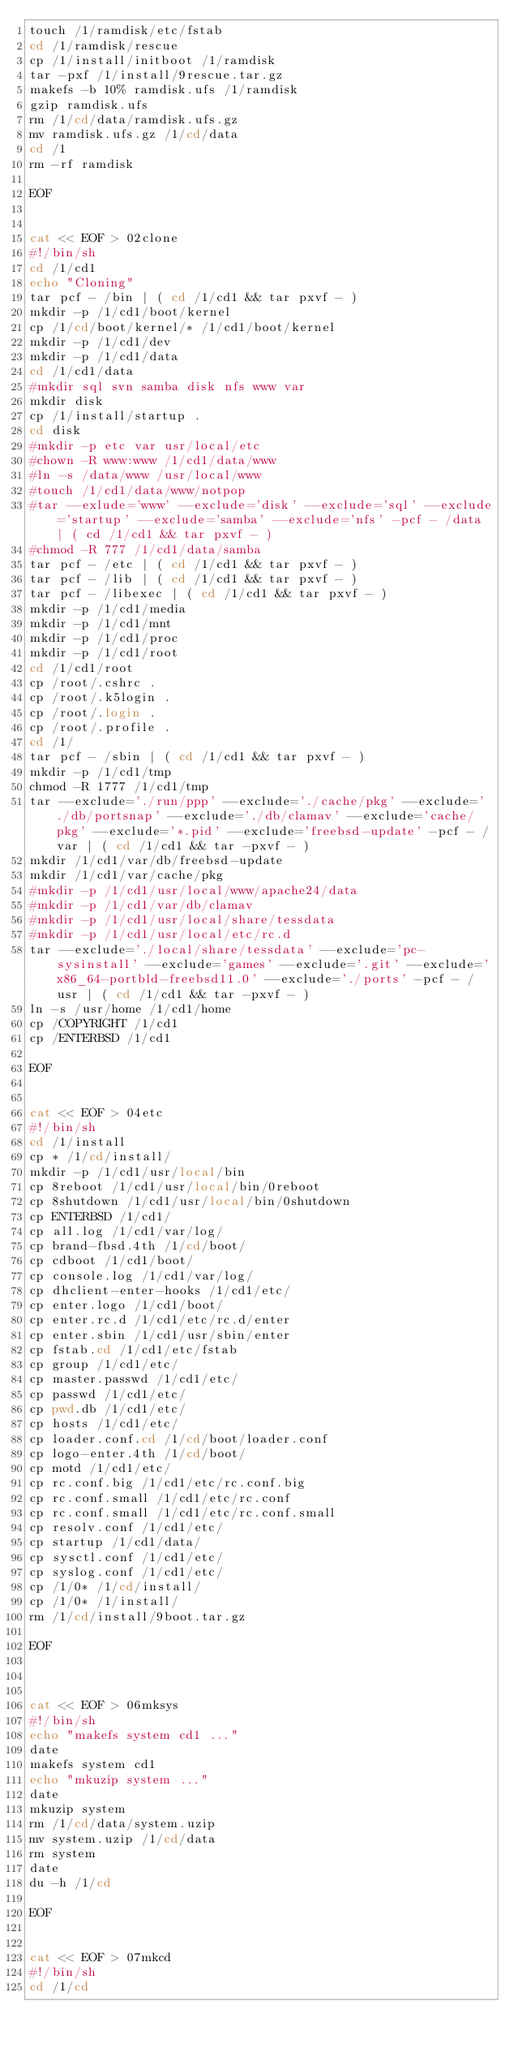Convert code to text. <code><loc_0><loc_0><loc_500><loc_500><_Bash_>touch /1/ramdisk/etc/fstab
cd /1/ramdisk/rescue
cp /1/install/initboot /1/ramdisk
tar -pxf /1/install/9rescue.tar.gz
makefs -b 10% ramdisk.ufs /1/ramdisk
gzip ramdisk.ufs
rm /1/cd/data/ramdisk.ufs.gz
mv ramdisk.ufs.gz /1/cd/data
cd /1
rm -rf ramdisk

EOF


cat << EOF > 02clone 
#!/bin/sh
cd /1/cd1
echo "Cloning"
tar pcf - /bin | ( cd /1/cd1 && tar pxvf - )
mkdir -p /1/cd1/boot/kernel
cp /1/cd/boot/kernel/* /1/cd1/boot/kernel
mkdir -p /1/cd1/dev
mkdir -p /1/cd1/data
cd /1/cd1/data
#mkdir sql svn samba disk nfs www var
mkdir disk
cp /1/install/startup .
cd disk
#mkdir -p etc var usr/local/etc
#chown -R www:www /1/cd1/data/www
#ln -s /data/www /usr/local/www
#touch /1/cd1/data/www/notpop
#tar --exlude='www' --exclude='disk' --exclude='sql' --exclude='startup' --exclude='samba' --exclude='nfs' -pcf - /data | ( cd /1/cd1 && tar pxvf - )
#chmod -R 777 /1/cd1/data/samba
tar pcf - /etc | ( cd /1/cd1 && tar pxvf - )
tar pcf - /lib | ( cd /1/cd1 && tar pxvf - )
tar pcf - /libexec | ( cd /1/cd1 && tar pxvf - )
mkdir -p /1/cd1/media
mkdir -p /1/cd1/mnt
mkdir -p /1/cd1/proc
mkdir -p /1/cd1/root
cd /1/cd1/root
cp /root/.cshrc .
cp /root/.k5login .
cp /root/.login .
cp /root/.profile .
cd /1/
tar pcf - /sbin | ( cd /1/cd1 && tar pxvf - )
mkdir -p /1/cd1/tmp
chmod -R 1777 /1/cd1/tmp
tar --exclude='./run/ppp' --exclude='./cache/pkg' --exclude='./db/portsnap' --exclude='./db/clamav' --exclude='cache/pkg' --exclude='*.pid' --exclude='freebsd-update' -pcf - /var | ( cd /1/cd1 && tar -pxvf - )
mkdir /1/cd1/var/db/freebsd-update
mkdir /1/cd1/var/cache/pkg
#mkdir -p /1/cd1/usr/local/www/apache24/data
#mkdir -p /1/cd1/var/db/clamav
#mkdir -p /1/cd1/usr/local/share/tessdata
#mkdir -p /1/cd1/usr/local/etc/rc.d
tar --exclude='./local/share/tessdata' --exclude='pc-sysinstall' --exclude='games' --exclude='.git' --exclude='x86_64-portbld-freebsd11.0' --exclude='./ports' -pcf - /usr | ( cd /1/cd1 && tar -pxvf - )
ln -s /usr/home /1/cd1/home
cp /COPYRIGHT /1/cd1
cp /ENTERBSD /1/cd1

EOF


cat << EOF > 04etc 
#!/bin/sh
cd /1/install
cp * /1/cd/install/
mkdir -p /1/cd1/usr/local/bin
cp 8reboot /1/cd1/usr/local/bin/0reboot
cp 8shutdown /1/cd1/usr/local/bin/0shutdown
cp ENTERBSD /1/cd1/
cp all.log /1/cd1/var/log/
cp brand-fbsd.4th /1/cd/boot/
cp cdboot /1/cd1/boot/
cp console.log /1/cd1/var/log/
cp dhclient-enter-hooks /1/cd1/etc/
cp enter.logo /1/cd1/boot/
cp enter.rc.d /1/cd1/etc/rc.d/enter
cp enter.sbin /1/cd1/usr/sbin/enter
cp fstab.cd /1/cd1/etc/fstab
cp group /1/cd1/etc/
cp master.passwd /1/cd1/etc/
cp passwd /1/cd1/etc/
cp pwd.db /1/cd1/etc/
cp hosts /1/cd1/etc/
cp loader.conf.cd /1/cd/boot/loader.conf
cp logo-enter.4th /1/cd/boot/
cp motd /1/cd1/etc/
cp rc.conf.big /1/cd1/etc/rc.conf.big
cp rc.conf.small /1/cd1/etc/rc.conf
cp rc.conf.small /1/cd1/etc/rc.conf.small
cp resolv.conf /1/cd1/etc/
cp startup /1/cd1/data/
cp sysctl.conf /1/cd1/etc/
cp syslog.conf /1/cd1/etc/
cp /1/0* /1/cd/install/
cp /1/0* /1/install/
rm /1/cd/install/9boot.tar.gz

EOF



cat << EOF > 06mksys 
#!/bin/sh
echo "makefs system cd1 ..."
date
makefs system cd1
echo "mkuzip system ..."
date
mkuzip system
rm /1/cd/data/system.uzip
mv system.uzip /1/cd/data
rm system
date
du -h /1/cd

EOF


cat << EOF > 07mkcd 
#!/bin/sh
cd /1/cd</code> 